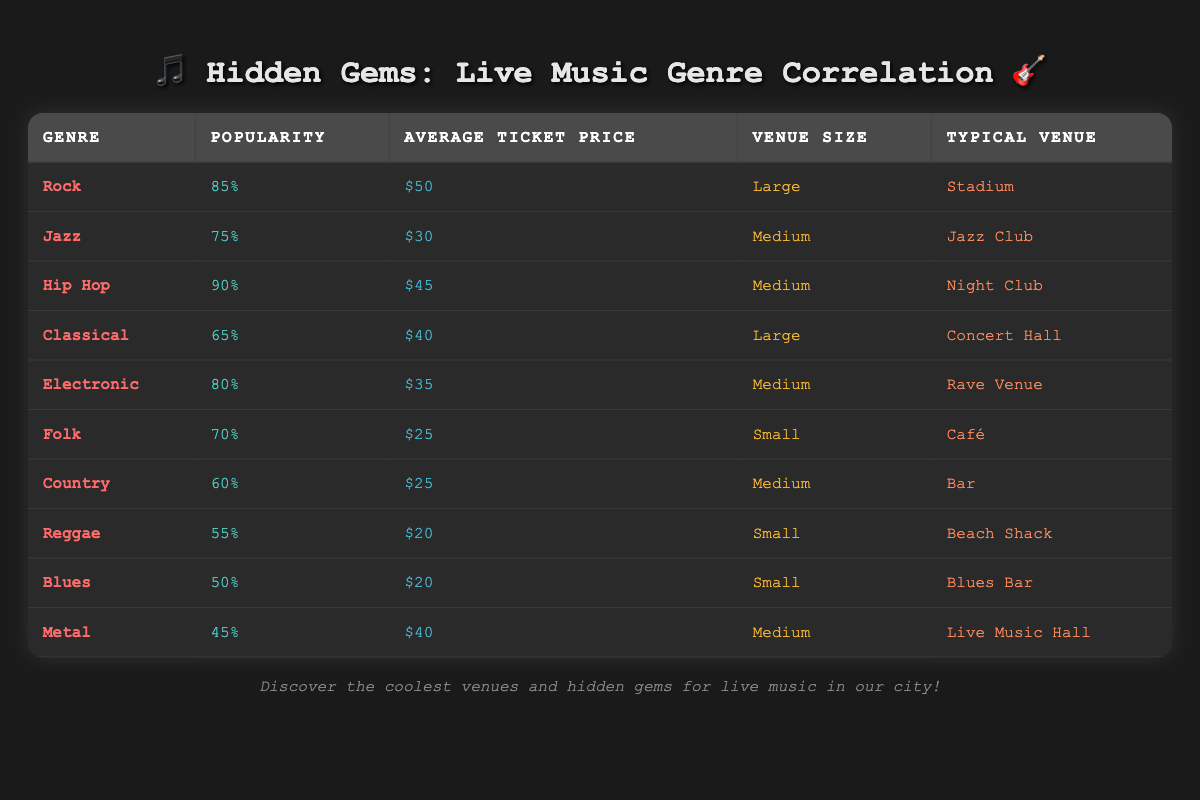What is the genre with the highest popularity? The table lists the popularity of different genres. Looking at the Popularity column, Hip Hop has the highest value which is 90.
Answer: Hip Hop Which venue type is typically associated with Classical music? According to the Typical Venue column for the Classical genre, it is a Concert Hall.
Answer: Concert Hall What is the average ticket price for Medium-sized venues? The ticket prices for Medium venues (Hip Hop, Jazz, Electronic, Country, Metal) are $45, $30, $35, $25, and $40, respectively. The sum is (45 + 30 + 35 + 25 + 40) = 175. There are 5 Medium venues, so the average is 175/5 = 35.
Answer: 35 Is the popularity of Folk music greater than that of Reggae music? Checking the Popularity values, Folk has a popularity of 70 and Reggae has a popularity of 55. Since 70 is greater than 55, the statement is true.
Answer: Yes What is the combination of the average ticket prices for Large and Small venue genres? The Average Ticket Prices for Large venues (Rock: $50, Classical: $40) total to $90, and for Small venues (Folk: $25, Reggae: $20, Blues: $20) total to $65. Combining both sums: 90 + 65 = 155.
Answer: 155 How many genres have a popularity below 60? From the popularity values, the genres with popularity below 60 are Country (60), Reggae (55), Blues (50), and Metal (45). There are 4 genres with popularity below 60, as only Country is exactly 60.
Answer: 3 What is the least expensive genre for live music? Checking the Average Ticket Price column, Folk and Reggae both have the lowest price at $25, making them the least expensive.
Answer: Folk and Reggae What is the highest average ticket price among the genres listed? Observing the Average Ticket Price column, Rock at $50 has the highest value compared to others, which are all lower.
Answer: $50 How does the Popularity of Electronic music compare to that of Classical music? Electronic has a popularity of 80 while Classical has 65. Since 80 is higher than 65, Electronic is more popular than Classical.
Answer: Electronic is more popular 